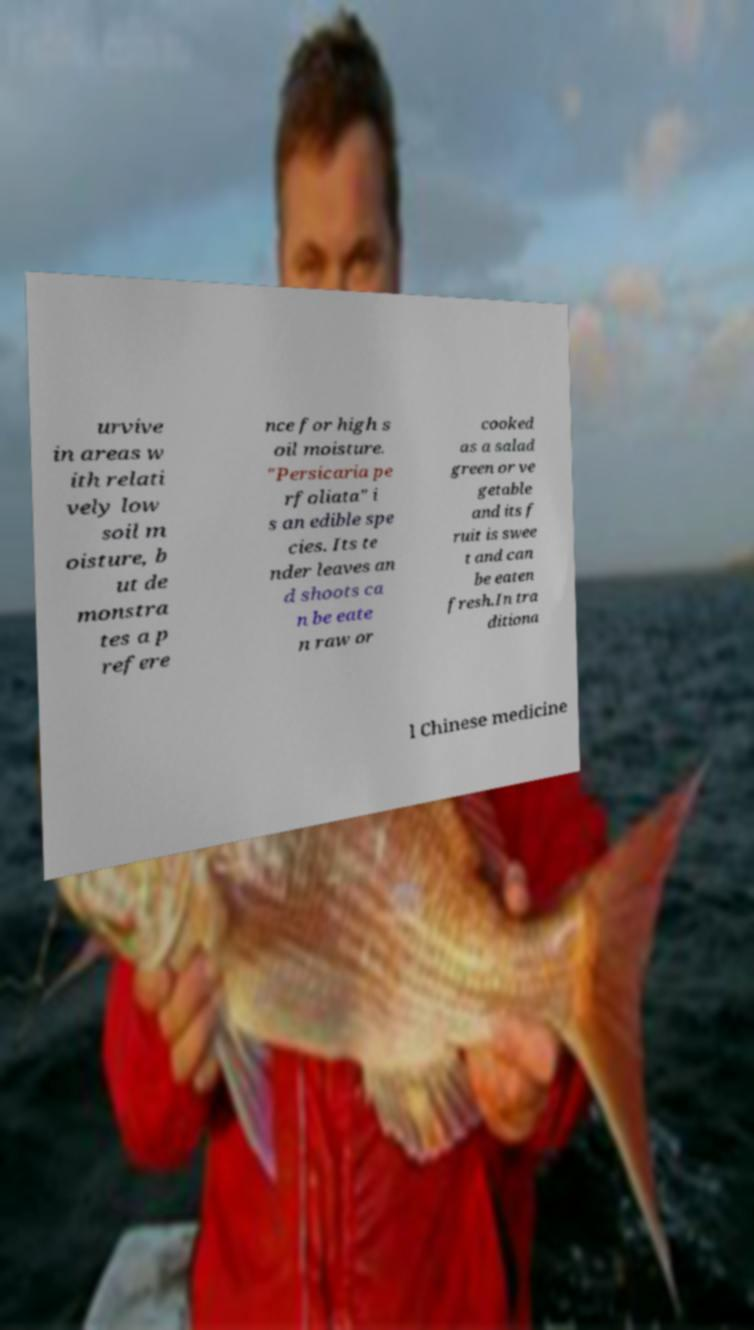I need the written content from this picture converted into text. Can you do that? urvive in areas w ith relati vely low soil m oisture, b ut de monstra tes a p refere nce for high s oil moisture. "Persicaria pe rfoliata" i s an edible spe cies. Its te nder leaves an d shoots ca n be eate n raw or cooked as a salad green or ve getable and its f ruit is swee t and can be eaten fresh.In tra ditiona l Chinese medicine 